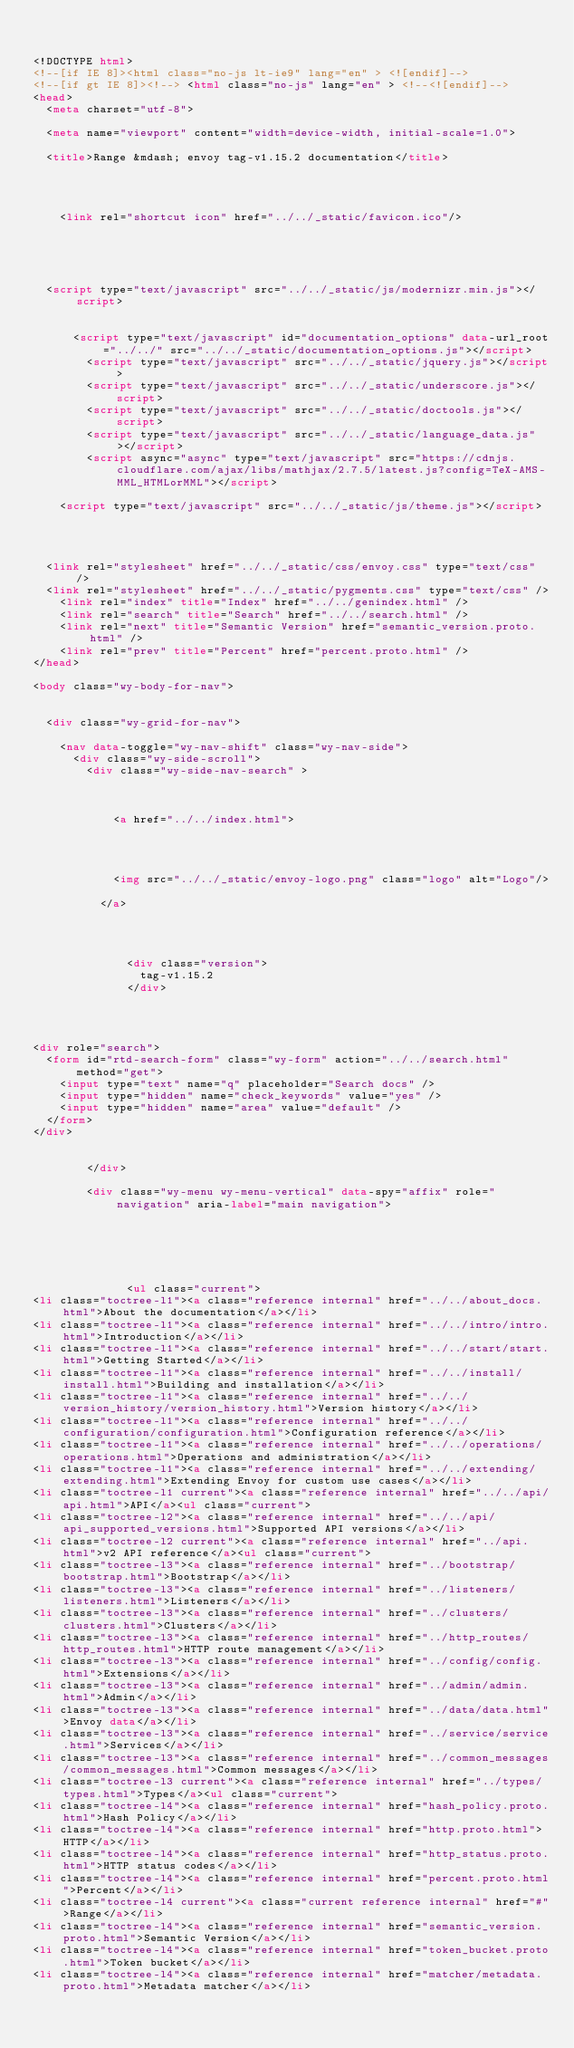Convert code to text. <code><loc_0><loc_0><loc_500><loc_500><_HTML_>

<!DOCTYPE html>
<!--[if IE 8]><html class="no-js lt-ie9" lang="en" > <![endif]-->
<!--[if gt IE 8]><!--> <html class="no-js" lang="en" > <!--<![endif]-->
<head>
  <meta charset="utf-8">
  
  <meta name="viewport" content="width=device-width, initial-scale=1.0">
  
  <title>Range &mdash; envoy tag-v1.15.2 documentation</title>
  

  
  
    <link rel="shortcut icon" href="../../_static/favicon.ico"/>
  
  
  

  
  <script type="text/javascript" src="../../_static/js/modernizr.min.js"></script>
  
    
      <script type="text/javascript" id="documentation_options" data-url_root="../../" src="../../_static/documentation_options.js"></script>
        <script type="text/javascript" src="../../_static/jquery.js"></script>
        <script type="text/javascript" src="../../_static/underscore.js"></script>
        <script type="text/javascript" src="../../_static/doctools.js"></script>
        <script type="text/javascript" src="../../_static/language_data.js"></script>
        <script async="async" type="text/javascript" src="https://cdnjs.cloudflare.com/ajax/libs/mathjax/2.7.5/latest.js?config=TeX-AMS-MML_HTMLorMML"></script>
    
    <script type="text/javascript" src="../../_static/js/theme.js"></script>

    

  
  <link rel="stylesheet" href="../../_static/css/envoy.css" type="text/css" />
  <link rel="stylesheet" href="../../_static/pygments.css" type="text/css" />
    <link rel="index" title="Index" href="../../genindex.html" />
    <link rel="search" title="Search" href="../../search.html" />
    <link rel="next" title="Semantic Version" href="semantic_version.proto.html" />
    <link rel="prev" title="Percent" href="percent.proto.html" /> 
</head>

<body class="wy-body-for-nav">

   
  <div class="wy-grid-for-nav">
    
    <nav data-toggle="wy-nav-shift" class="wy-nav-side">
      <div class="wy-side-scroll">
        <div class="wy-side-nav-search" >
          

          
            <a href="../../index.html">
          

          
            
            <img src="../../_static/envoy-logo.png" class="logo" alt="Logo"/>
          
          </a>

          
            
            
              <div class="version">
                tag-v1.15.2
              </div>
            
          

          
<div role="search">
  <form id="rtd-search-form" class="wy-form" action="../../search.html" method="get">
    <input type="text" name="q" placeholder="Search docs" />
    <input type="hidden" name="check_keywords" value="yes" />
    <input type="hidden" name="area" value="default" />
  </form>
</div>

          
        </div>

        <div class="wy-menu wy-menu-vertical" data-spy="affix" role="navigation" aria-label="main navigation">
          
            
            
              
            
            
              <ul class="current">
<li class="toctree-l1"><a class="reference internal" href="../../about_docs.html">About the documentation</a></li>
<li class="toctree-l1"><a class="reference internal" href="../../intro/intro.html">Introduction</a></li>
<li class="toctree-l1"><a class="reference internal" href="../../start/start.html">Getting Started</a></li>
<li class="toctree-l1"><a class="reference internal" href="../../install/install.html">Building and installation</a></li>
<li class="toctree-l1"><a class="reference internal" href="../../version_history/version_history.html">Version history</a></li>
<li class="toctree-l1"><a class="reference internal" href="../../configuration/configuration.html">Configuration reference</a></li>
<li class="toctree-l1"><a class="reference internal" href="../../operations/operations.html">Operations and administration</a></li>
<li class="toctree-l1"><a class="reference internal" href="../../extending/extending.html">Extending Envoy for custom use cases</a></li>
<li class="toctree-l1 current"><a class="reference internal" href="../../api/api.html">API</a><ul class="current">
<li class="toctree-l2"><a class="reference internal" href="../../api/api_supported_versions.html">Supported API versions</a></li>
<li class="toctree-l2 current"><a class="reference internal" href="../api.html">v2 API reference</a><ul class="current">
<li class="toctree-l3"><a class="reference internal" href="../bootstrap/bootstrap.html">Bootstrap</a></li>
<li class="toctree-l3"><a class="reference internal" href="../listeners/listeners.html">Listeners</a></li>
<li class="toctree-l3"><a class="reference internal" href="../clusters/clusters.html">Clusters</a></li>
<li class="toctree-l3"><a class="reference internal" href="../http_routes/http_routes.html">HTTP route management</a></li>
<li class="toctree-l3"><a class="reference internal" href="../config/config.html">Extensions</a></li>
<li class="toctree-l3"><a class="reference internal" href="../admin/admin.html">Admin</a></li>
<li class="toctree-l3"><a class="reference internal" href="../data/data.html">Envoy data</a></li>
<li class="toctree-l3"><a class="reference internal" href="../service/service.html">Services</a></li>
<li class="toctree-l3"><a class="reference internal" href="../common_messages/common_messages.html">Common messages</a></li>
<li class="toctree-l3 current"><a class="reference internal" href="../types/types.html">Types</a><ul class="current">
<li class="toctree-l4"><a class="reference internal" href="hash_policy.proto.html">Hash Policy</a></li>
<li class="toctree-l4"><a class="reference internal" href="http.proto.html">HTTP</a></li>
<li class="toctree-l4"><a class="reference internal" href="http_status.proto.html">HTTP status codes</a></li>
<li class="toctree-l4"><a class="reference internal" href="percent.proto.html">Percent</a></li>
<li class="toctree-l4 current"><a class="current reference internal" href="#">Range</a></li>
<li class="toctree-l4"><a class="reference internal" href="semantic_version.proto.html">Semantic Version</a></li>
<li class="toctree-l4"><a class="reference internal" href="token_bucket.proto.html">Token bucket</a></li>
<li class="toctree-l4"><a class="reference internal" href="matcher/metadata.proto.html">Metadata matcher</a></li></code> 